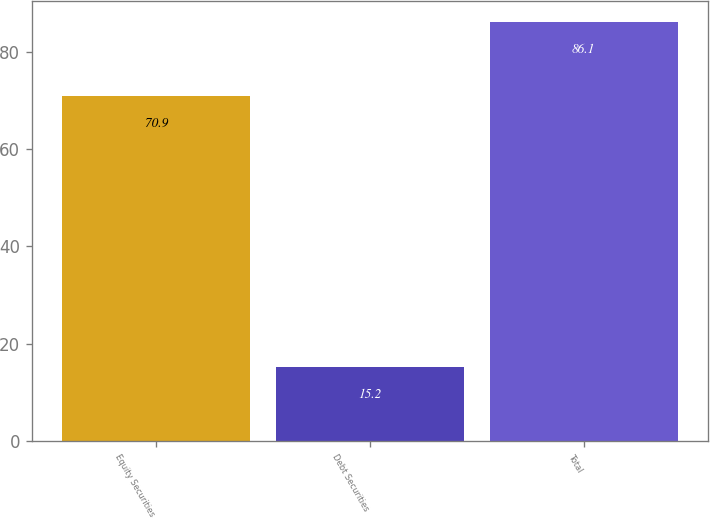Convert chart. <chart><loc_0><loc_0><loc_500><loc_500><bar_chart><fcel>Equity Securities<fcel>Debt Securities<fcel>Total<nl><fcel>70.9<fcel>15.2<fcel>86.1<nl></chart> 